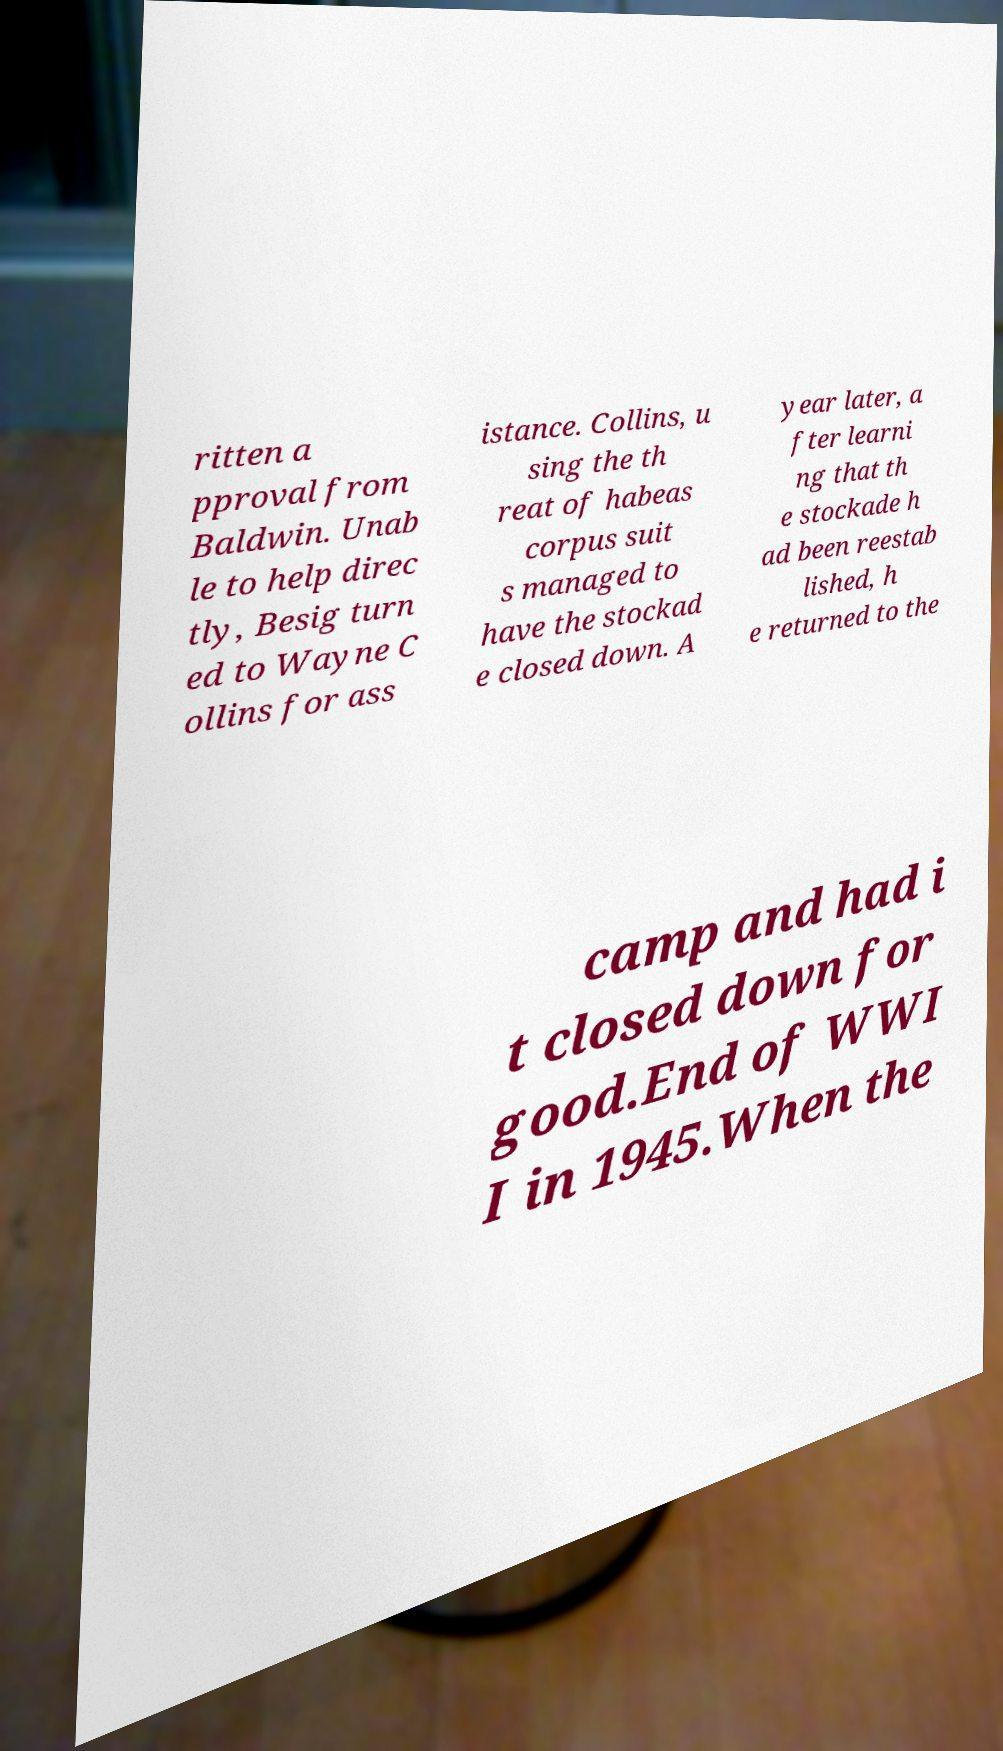What messages or text are displayed in this image? I need them in a readable, typed format. ritten a pproval from Baldwin. Unab le to help direc tly, Besig turn ed to Wayne C ollins for ass istance. Collins, u sing the th reat of habeas corpus suit s managed to have the stockad e closed down. A year later, a fter learni ng that th e stockade h ad been reestab lished, h e returned to the camp and had i t closed down for good.End of WWI I in 1945.When the 